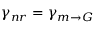Convert formula to latex. <formula><loc_0><loc_0><loc_500><loc_500>\gamma _ { n r } = \gamma _ { m \rightarrow G }</formula> 